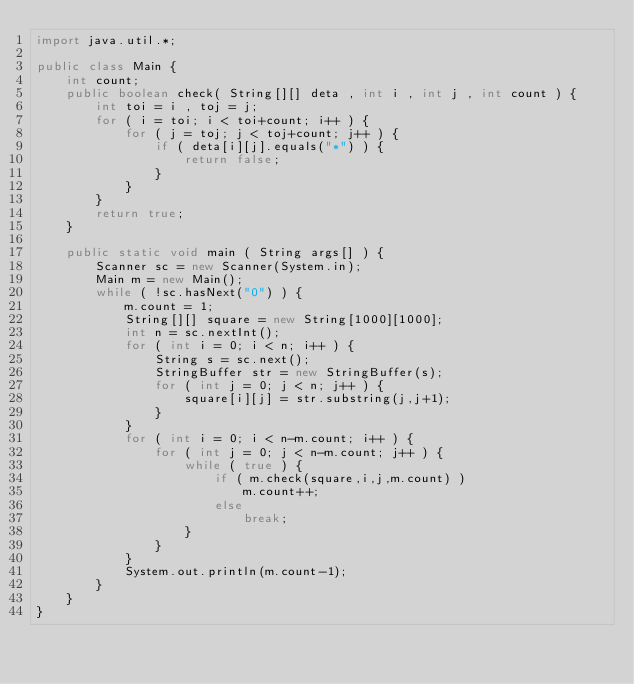<code> <loc_0><loc_0><loc_500><loc_500><_Java_>import java.util.*;

public class Main {
	int count;
	public boolean check( String[][] deta , int i , int j , int count ) {
		int toi = i , toj = j;
		for ( i = toi; i < toi+count; i++ ) {
			for ( j = toj; j < toj+count; j++ ) {
				if ( deta[i][j].equals("*") ) {
					return false;
				}
			}
		}
		return true;
	}
	
	public static void main ( String args[] ) {
		Scanner sc = new Scanner(System.in);
		Main m = new Main();
		while ( !sc.hasNext("0") ) {
			m.count = 1;
			String[][] square = new String[1000][1000];
			int n = sc.nextInt();
			for ( int i = 0; i < n; i++ ) {
				String s = sc.next();
				StringBuffer str = new StringBuffer(s); 
				for ( int j = 0; j < n; j++ ) {
					square[i][j] = str.substring(j,j+1);
				}
			}
			for ( int i = 0; i < n-m.count; i++ ) {
				for ( int j = 0; j < n-m.count; j++ ) {
					while ( true ) {
						if ( m.check(square,i,j,m.count) )
							m.count++;
						else
							break;
					}
				}
			}
			System.out.println(m.count-1);
		}
	}
}</code> 